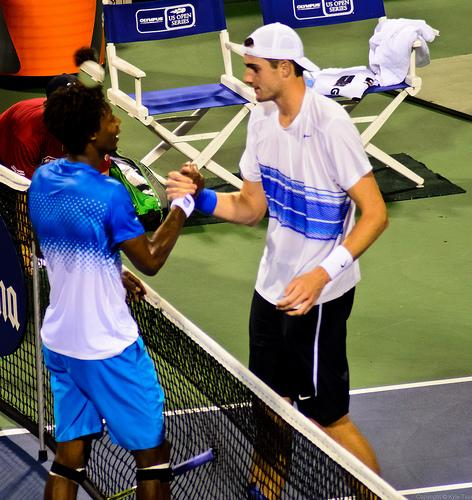Provide a brief description of the primary action taking place in the image. Two people are shaking hands on a tennis court with other individuals present around them. Mention the most prominent interaction occurring in the picture. The focal point of the image is the two individuals shaking hands on the tennis court. In one sentence, explain the main action happening in the image. Two individuals are shaking hands in the midst of a gathering on a tennis court. What is the central occurrence in the image that catches your attention? The key event is two people shaking hands on a tennis court with multiple people around. What is a noteworthy activity happening within the photograph? A pair of individuals can be seen engaging in a friendly handshake on a tennis court. What significant event is visible in the photograph? A handshake between two people on a tennis court surrounded by various people. Summarize the main event of the scene in one sentence. Two people exchanging handshakes on a tennis court surrounded by others. Briefly mention the key interaction taking place in the image. The primary interaction is a handshake between two individuals on a tennis court. State the main activity present in the photo in a concise manner. Two people are seen in the act of shaking hands on a busy tennis court. Describe the primary scene unfolding within the photo concisely. A friendly handshake is taking place between two people on the tennis court. 